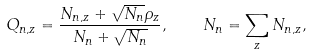<formula> <loc_0><loc_0><loc_500><loc_500>Q _ { n , z } = \frac { N _ { n , z } + \sqrt { N _ { n } } \rho _ { z } } { N _ { n } + \sqrt { N _ { n } } } , \quad N _ { n } = \sum _ { z } N _ { n , z } ,</formula> 